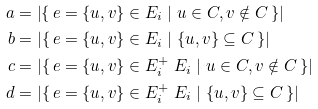<formula> <loc_0><loc_0><loc_500><loc_500>a & = \left | \{ \, e = \{ u , v \} \in E _ { i } \ | \ u \in C , v \notin C \, \} \right | \\ b & = | \{ \, e = \{ u , v \} \in E _ { i } \ | \ \{ u , v \} \subseteq C \, \} | \\ c & = | \{ \, e = \{ u , v \} \in E _ { i } ^ { + } \ E _ { i } \ | \ u \in C , v \notin C \, \} | \\ d & = | \{ \, e = \{ u , v \} \in E _ { i } ^ { + } \ E _ { i } \ | \ \{ u , v \} \subseteq C \, \} |</formula> 